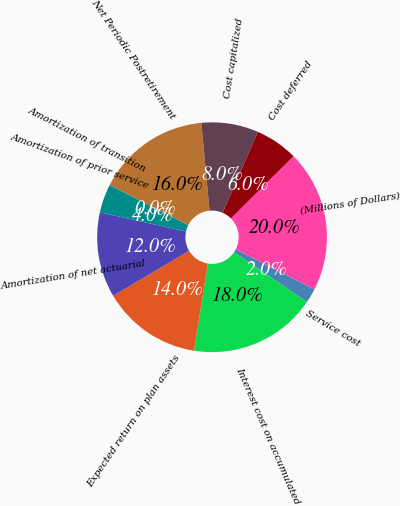Convert chart to OTSL. <chart><loc_0><loc_0><loc_500><loc_500><pie_chart><fcel>(Millions of Dollars)<fcel>Service cost<fcel>Interest cost on accumulated<fcel>Expected return on plan assets<fcel>Amortization of net actuarial<fcel>Amortization of prior service<fcel>Amortization of transition<fcel>Net Periodic Postretirement<fcel>Cost capitalized<fcel>Cost deferred<nl><fcel>19.96%<fcel>2.03%<fcel>17.97%<fcel>13.98%<fcel>11.99%<fcel>4.02%<fcel>0.04%<fcel>15.98%<fcel>8.01%<fcel>6.02%<nl></chart> 